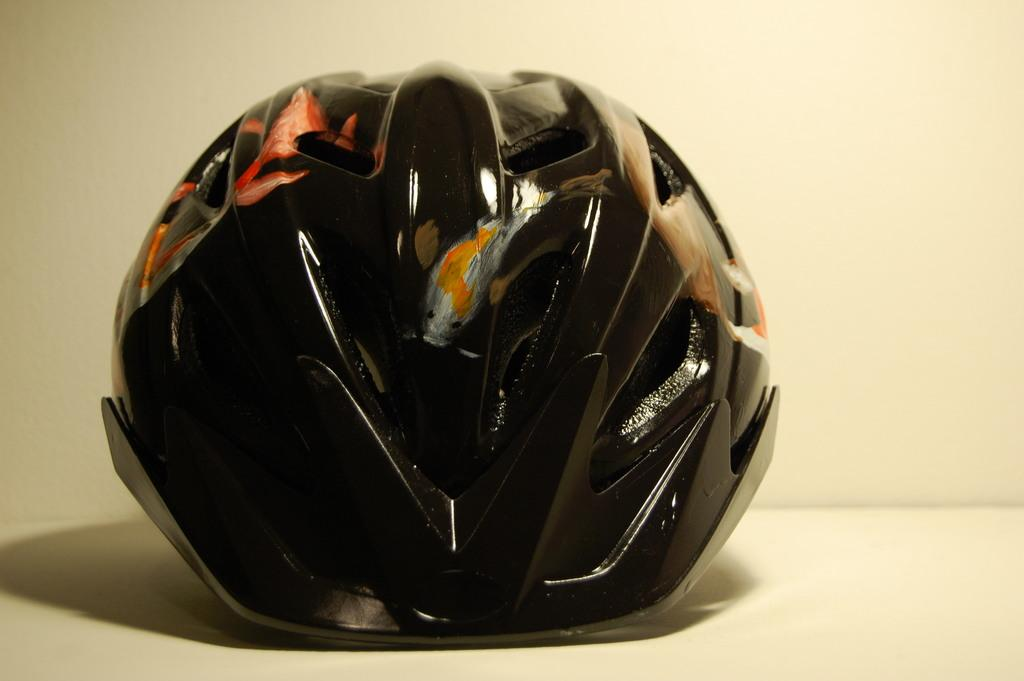What is the color of the object in the image? The object in the image is black. What is the color of the surface on which the object is placed? The surface is cream color. Where is the hen located in the image? There is no hen present in the image. What type of van can be seen parked near the object in the image? There is no van present in the image. 